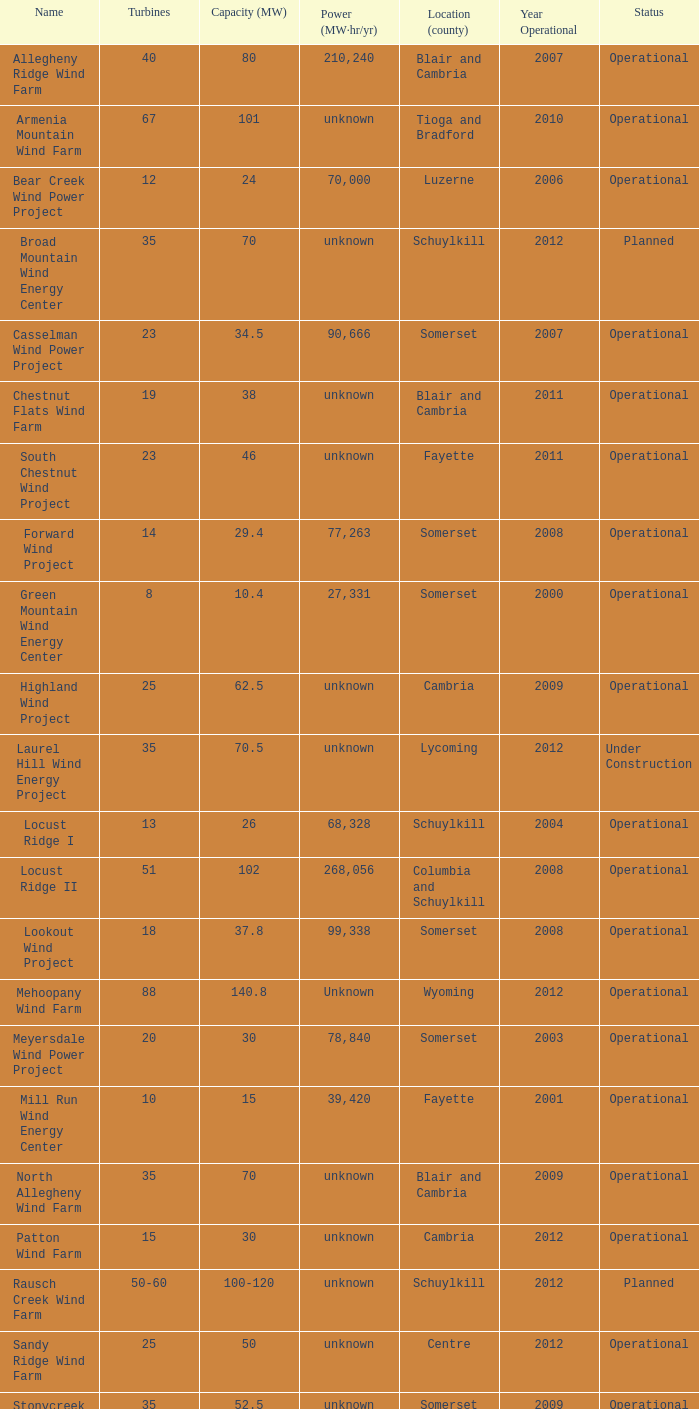What locations are considered centre? Unknown. 